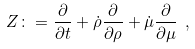<formula> <loc_0><loc_0><loc_500><loc_500>Z \colon = \frac { \partial } { \partial t } + \dot { \rho } \frac { \partial } { \partial \rho } + \dot { \mu } \frac { \partial } { \partial \mu } \ ,</formula> 